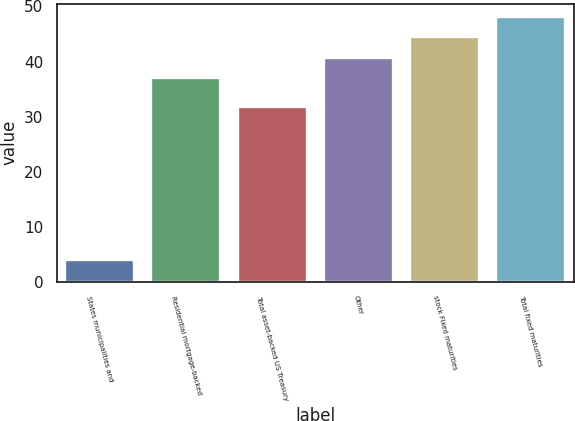<chart> <loc_0><loc_0><loc_500><loc_500><bar_chart><fcel>States municipalities and<fcel>Residential mortgage-backed<fcel>Total asset-backed US Treasury<fcel>Other<fcel>stock Fixed maturities<fcel>Total fixed maturities<nl><fcel>4<fcel>37<fcel>31.7<fcel>40.7<fcel>44.4<fcel>48.1<nl></chart> 